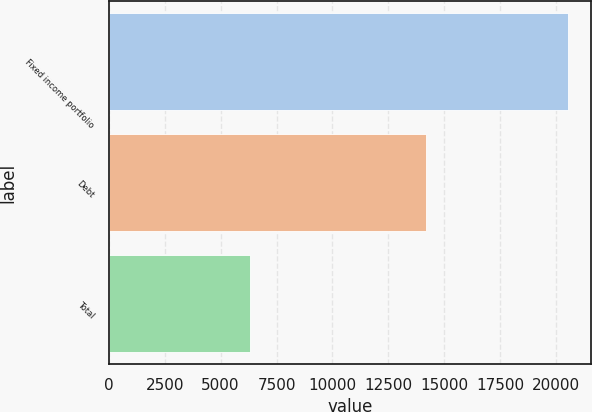<chart> <loc_0><loc_0><loc_500><loc_500><bar_chart><fcel>Fixed income portfolio<fcel>Debt<fcel>Total<nl><fcel>20530<fcel>14200<fcel>6330<nl></chart> 